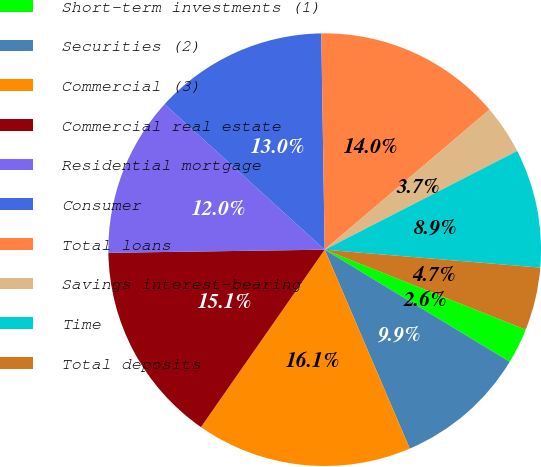<chart> <loc_0><loc_0><loc_500><loc_500><pie_chart><fcel>Short-term investments (1)<fcel>Securities (2)<fcel>Commercial (3)<fcel>Commercial real estate<fcel>Residential mortgage<fcel>Consumer<fcel>Total loans<fcel>Savings interest-bearing<fcel>Time<fcel>Total deposits<nl><fcel>2.64%<fcel>9.9%<fcel>16.12%<fcel>15.08%<fcel>11.97%<fcel>13.01%<fcel>14.04%<fcel>3.67%<fcel>8.86%<fcel>4.71%<nl></chart> 